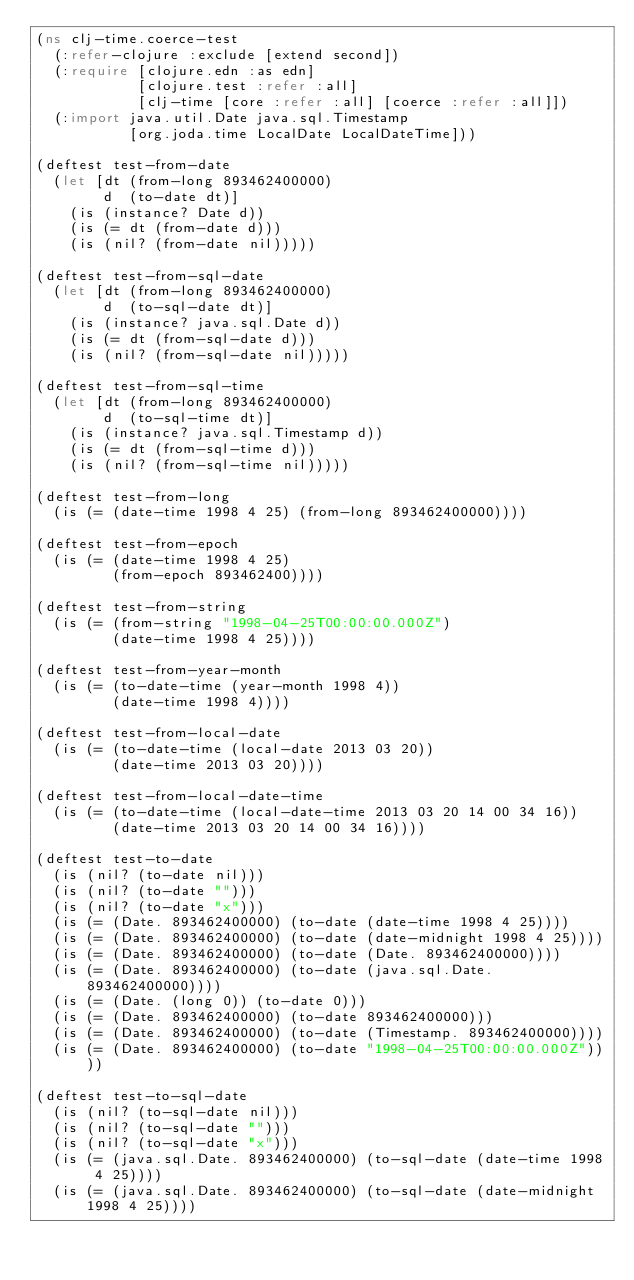Convert code to text. <code><loc_0><loc_0><loc_500><loc_500><_Clojure_>(ns clj-time.coerce-test
  (:refer-clojure :exclude [extend second])
  (:require [clojure.edn :as edn]
            [clojure.test :refer :all]
            [clj-time [core :refer :all] [coerce :refer :all]])
  (:import java.util.Date java.sql.Timestamp
           [org.joda.time LocalDate LocalDateTime]))

(deftest test-from-date
  (let [dt (from-long 893462400000)
        d  (to-date dt)]
    (is (instance? Date d))
    (is (= dt (from-date d)))
    (is (nil? (from-date nil)))))

(deftest test-from-sql-date
  (let [dt (from-long 893462400000)
        d  (to-sql-date dt)]
    (is (instance? java.sql.Date d))
    (is (= dt (from-sql-date d)))
    (is (nil? (from-sql-date nil)))))

(deftest test-from-sql-time
  (let [dt (from-long 893462400000)
        d  (to-sql-time dt)]
    (is (instance? java.sql.Timestamp d))
    (is (= dt (from-sql-time d)))
    (is (nil? (from-sql-time nil)))))

(deftest test-from-long
  (is (= (date-time 1998 4 25) (from-long 893462400000))))

(deftest test-from-epoch
  (is (= (date-time 1998 4 25)
         (from-epoch 893462400))))

(deftest test-from-string
  (is (= (from-string "1998-04-25T00:00:00.000Z")
         (date-time 1998 4 25))))

(deftest test-from-year-month
  (is (= (to-date-time (year-month 1998 4))
         (date-time 1998 4))))

(deftest test-from-local-date
  (is (= (to-date-time (local-date 2013 03 20))
         (date-time 2013 03 20))))

(deftest test-from-local-date-time
  (is (= (to-date-time (local-date-time 2013 03 20 14 00 34 16))
         (date-time 2013 03 20 14 00 34 16))))

(deftest test-to-date
  (is (nil? (to-date nil)))
  (is (nil? (to-date "")))
  (is (nil? (to-date "x")))
  (is (= (Date. 893462400000) (to-date (date-time 1998 4 25))))
  (is (= (Date. 893462400000) (to-date (date-midnight 1998 4 25))))
  (is (= (Date. 893462400000) (to-date (Date. 893462400000))))
  (is (= (Date. 893462400000) (to-date (java.sql.Date. 893462400000))))
  (is (= (Date. (long 0)) (to-date 0)))
  (is (= (Date. 893462400000) (to-date 893462400000)))
  (is (= (Date. 893462400000) (to-date (Timestamp. 893462400000))))
  (is (= (Date. 893462400000) (to-date "1998-04-25T00:00:00.000Z"))))

(deftest test-to-sql-date
  (is (nil? (to-sql-date nil)))
  (is (nil? (to-sql-date "")))
  (is (nil? (to-sql-date "x")))
  (is (= (java.sql.Date. 893462400000) (to-sql-date (date-time 1998 4 25))))
  (is (= (java.sql.Date. 893462400000) (to-sql-date (date-midnight 1998 4 25))))</code> 